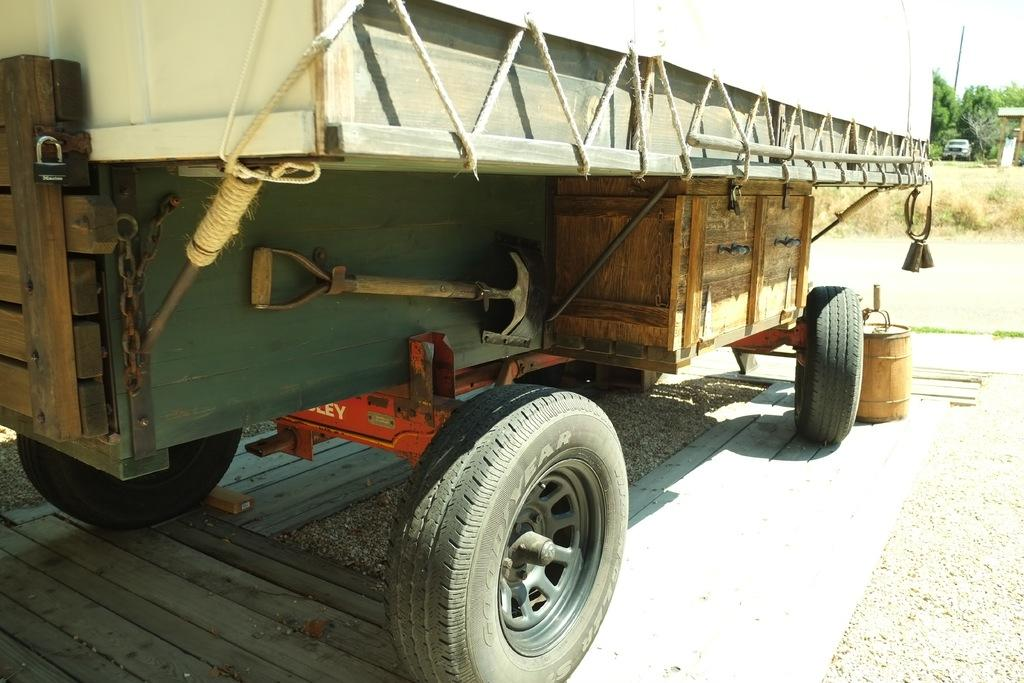What type of vehicle is in the image? There is a vehicle in the image, but the specific type is not mentioned. What can be seen on the path in the image? There are objects on the path in the image. What is the surface that the vehicle is traveling on in the image? The road is visible in the image, which is the surface the vehicle is traveling on. What type of terrain is present in the image? Land is present in the image, and grass is visible, indicating a grassy terrain. Are there any trees in the image? Yes, trees are present in the image. Can you see anything in the background of the image? There is a car in the background of the image. What is visible in the sky in the image? The sky is visible in the image. Where is the fire hydrant located in the image? There is no fire hydrant present in the image. What type of peace symbol can be seen in the image? There is no peace symbol present in the image. 